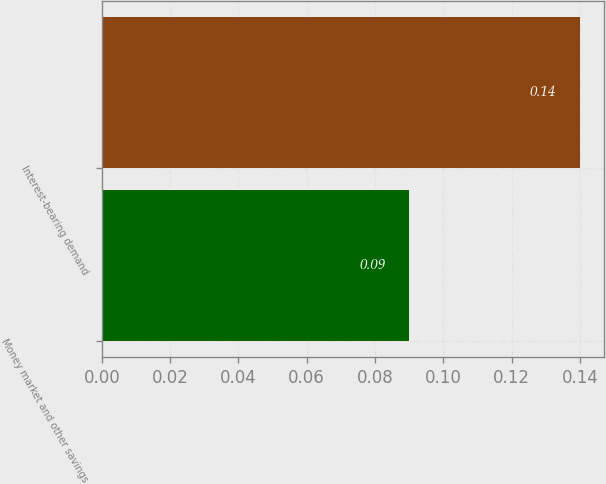Convert chart to OTSL. <chart><loc_0><loc_0><loc_500><loc_500><bar_chart><fcel>Money market and other savings<fcel>Interest-bearing demand<nl><fcel>0.09<fcel>0.14<nl></chart> 